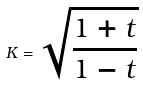<formula> <loc_0><loc_0><loc_500><loc_500>K = \sqrt { \frac { 1 + t } { 1 - t } }</formula> 